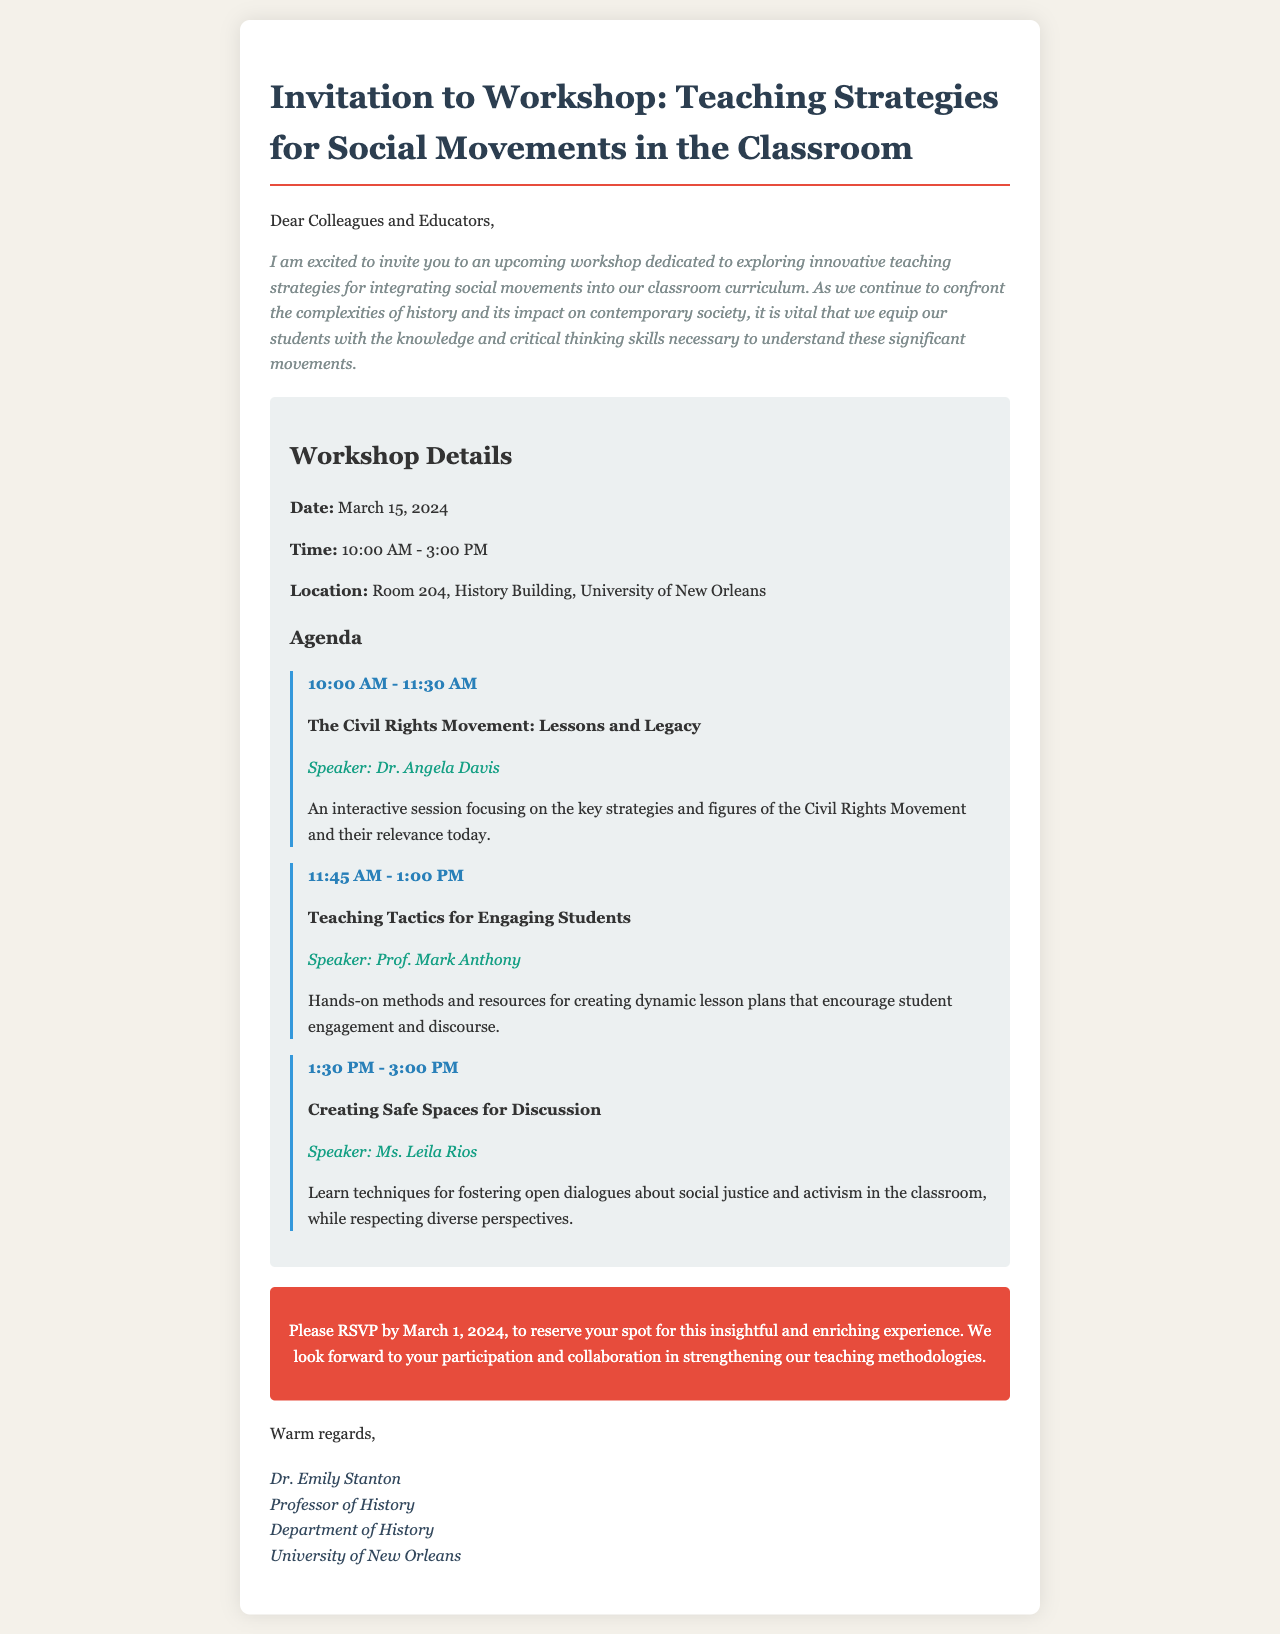What is the date of the workshop? The date of the workshop is specified in the document.
Answer: March 15, 2024 Who is the speaker for the session on the Civil Rights Movement? The document lists speakers for different sessions, including the session on the Civil Rights Movement.
Answer: Dr. Angela Davis What time does the workshop start? The starting time of the workshop is given in the document.
Answer: 10:00 AM What is the location of the workshop? The document provides the specific location where the workshop will be held.
Answer: Room 204, History Building, University of New Orleans What is the RSVP deadline? The document mentions a specific date by which participants should RSVP.
Answer: March 1, 2024 How long is the session on Teaching Tactics for Engaging Students? The document provides the duration of each session in the agenda.
Answer: 1 hour 15 minutes What is the main topic of the final session? Each session topic is included in the agenda of the document.
Answer: Creating Safe Spaces for Discussion What is the focus of the workshop as described in the introduction? The introduction of the document outlines the main focus of the workshop.
Answer: Innovative teaching strategies for integrating social movements into our classroom curriculum 